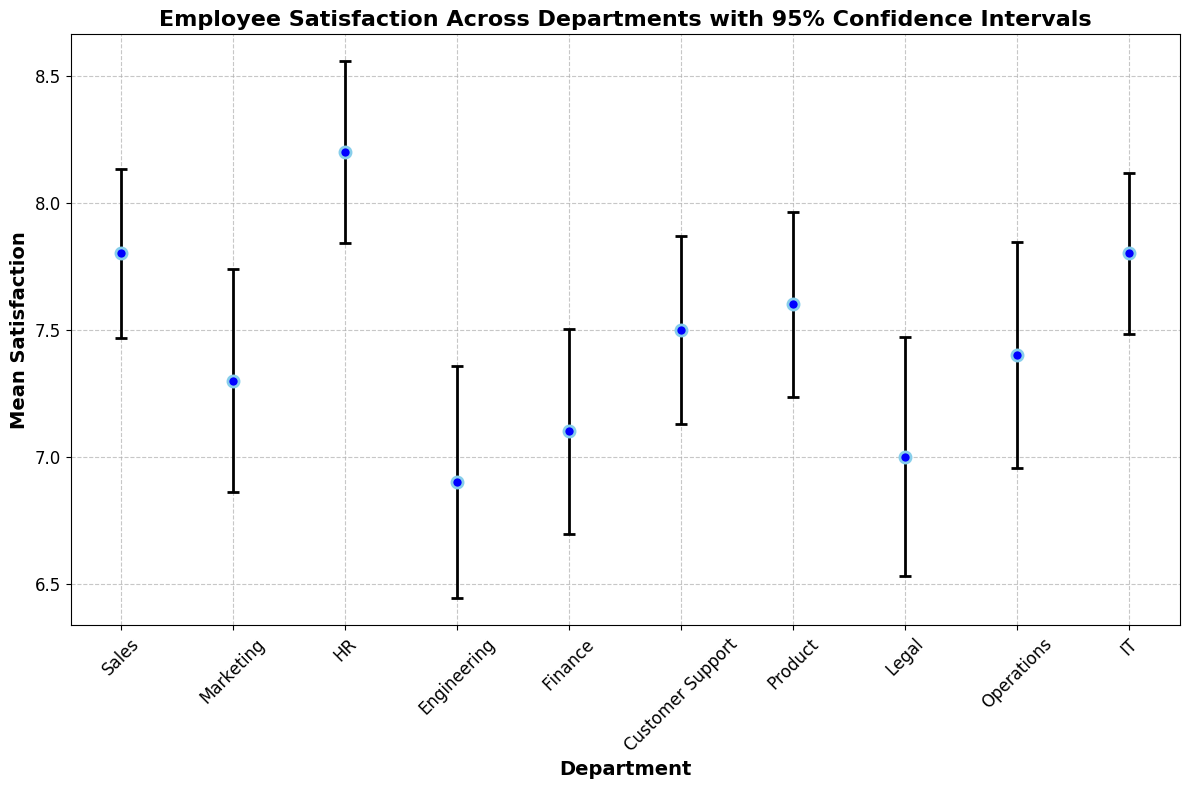What is the department with the highest mean satisfaction? According to the figure, HR has the highest mean satisfaction score.
Answer: HR Which department has the lowest mean satisfaction and what is its value? The figure shows that Engineering has the lowest mean satisfaction score.
Answer: Engineering, 6.9 How do the mean satisfaction scores of IT and Sales compare? By examining the figure, IT and Sales both have the same mean satisfaction score of 7.8.
Answer: They are equal What is the mean difference in satisfaction between the HR and Engineering departments? HR has a mean satisfaction of 8.2 and Engineering has 6.9. The difference is 8.2 - 6.9 = 1.3.
Answer: 1.3 Which departments have a mean satisfaction score greater than 7.5? The departments with mean satisfaction scores greater than 7.5 are Sales, HR, Customer Support, Product, and IT.
Answer: Sales, HR, Customer Support, Product, IT Between Legal and Finance, which department has a higher mean satisfaction score and by how much? Legal has a mean satisfaction score of 7.0, while Finance has 7.1. The difference is 7.1 - 7.0 = 0.1.
Answer: Finance, 0.1 Which department has the largest confidence interval and what is its length? By looking at the error bars, Engineering has the largest confidence interval. The confidence interval length can be calculated as 1.96 * 1.8 / sqrt(60) = 0.456.
Answer: Engineering, 0.456 What is the average mean satisfaction score across all departments? Sum of mean satisfaction scores is 7.8 + 7.3 + 8.2 + 6.9 + 7.1 + 7.5 + 7.6 + 7.0 + 7.4 + 7.8 = 74.6. The average is 74.6 / 10 = 7.46.
Answer: 7.46 